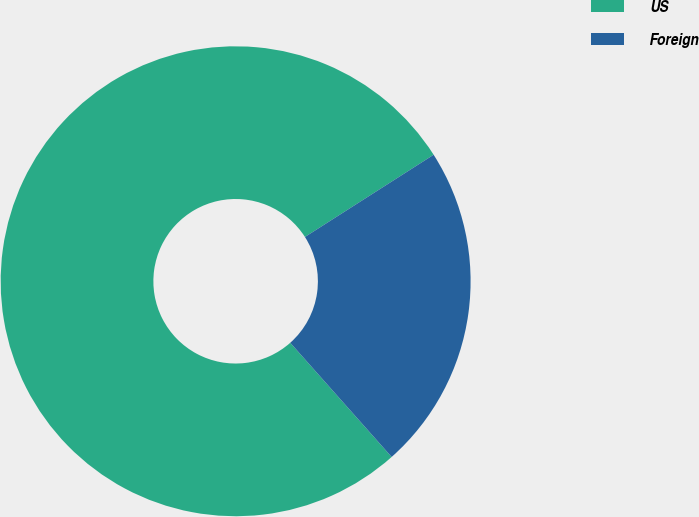Convert chart. <chart><loc_0><loc_0><loc_500><loc_500><pie_chart><fcel>US<fcel>Foreign<nl><fcel>77.51%<fcel>22.49%<nl></chart> 